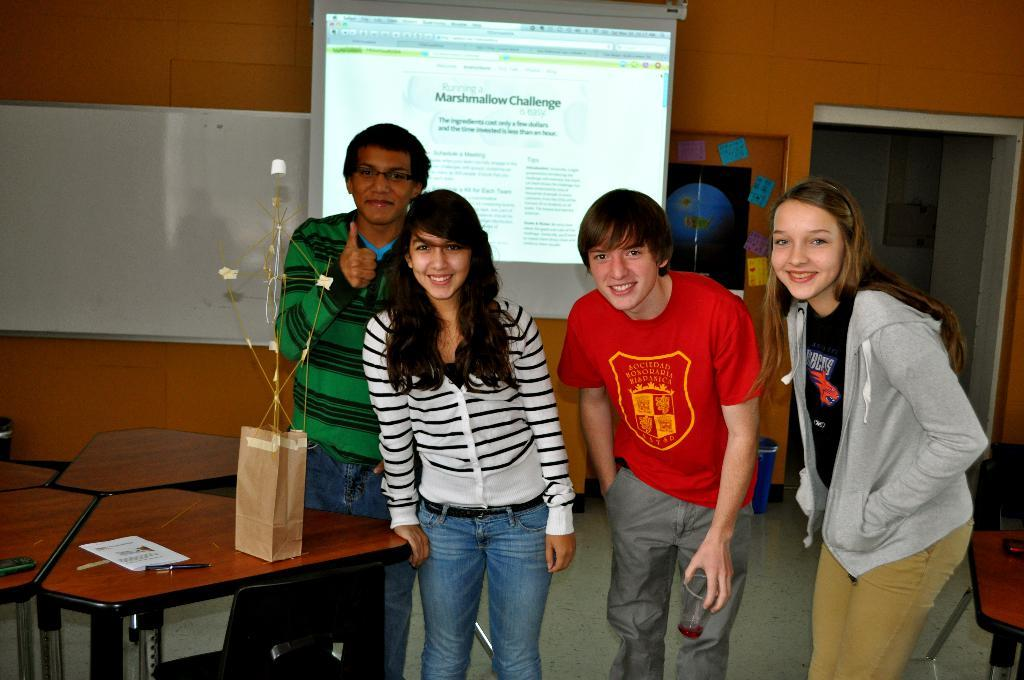How many people are in the room in the image? There are four people in the room. What are the people doing in the image? The people are standing and smiling. What is on the table in the room? There is a cover bag, a pen, and paper on the table. What can be seen in the background of the room? There is a projector and a wall in the background. How many sticks are being used by the people in the image? There are no sticks present in the image. What type of clover can be seen growing on the wall in the image? There is no clover present in the image; only a wall is visible in the background. 